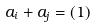<formula> <loc_0><loc_0><loc_500><loc_500>a _ { i } + a _ { j } = ( 1 )</formula> 